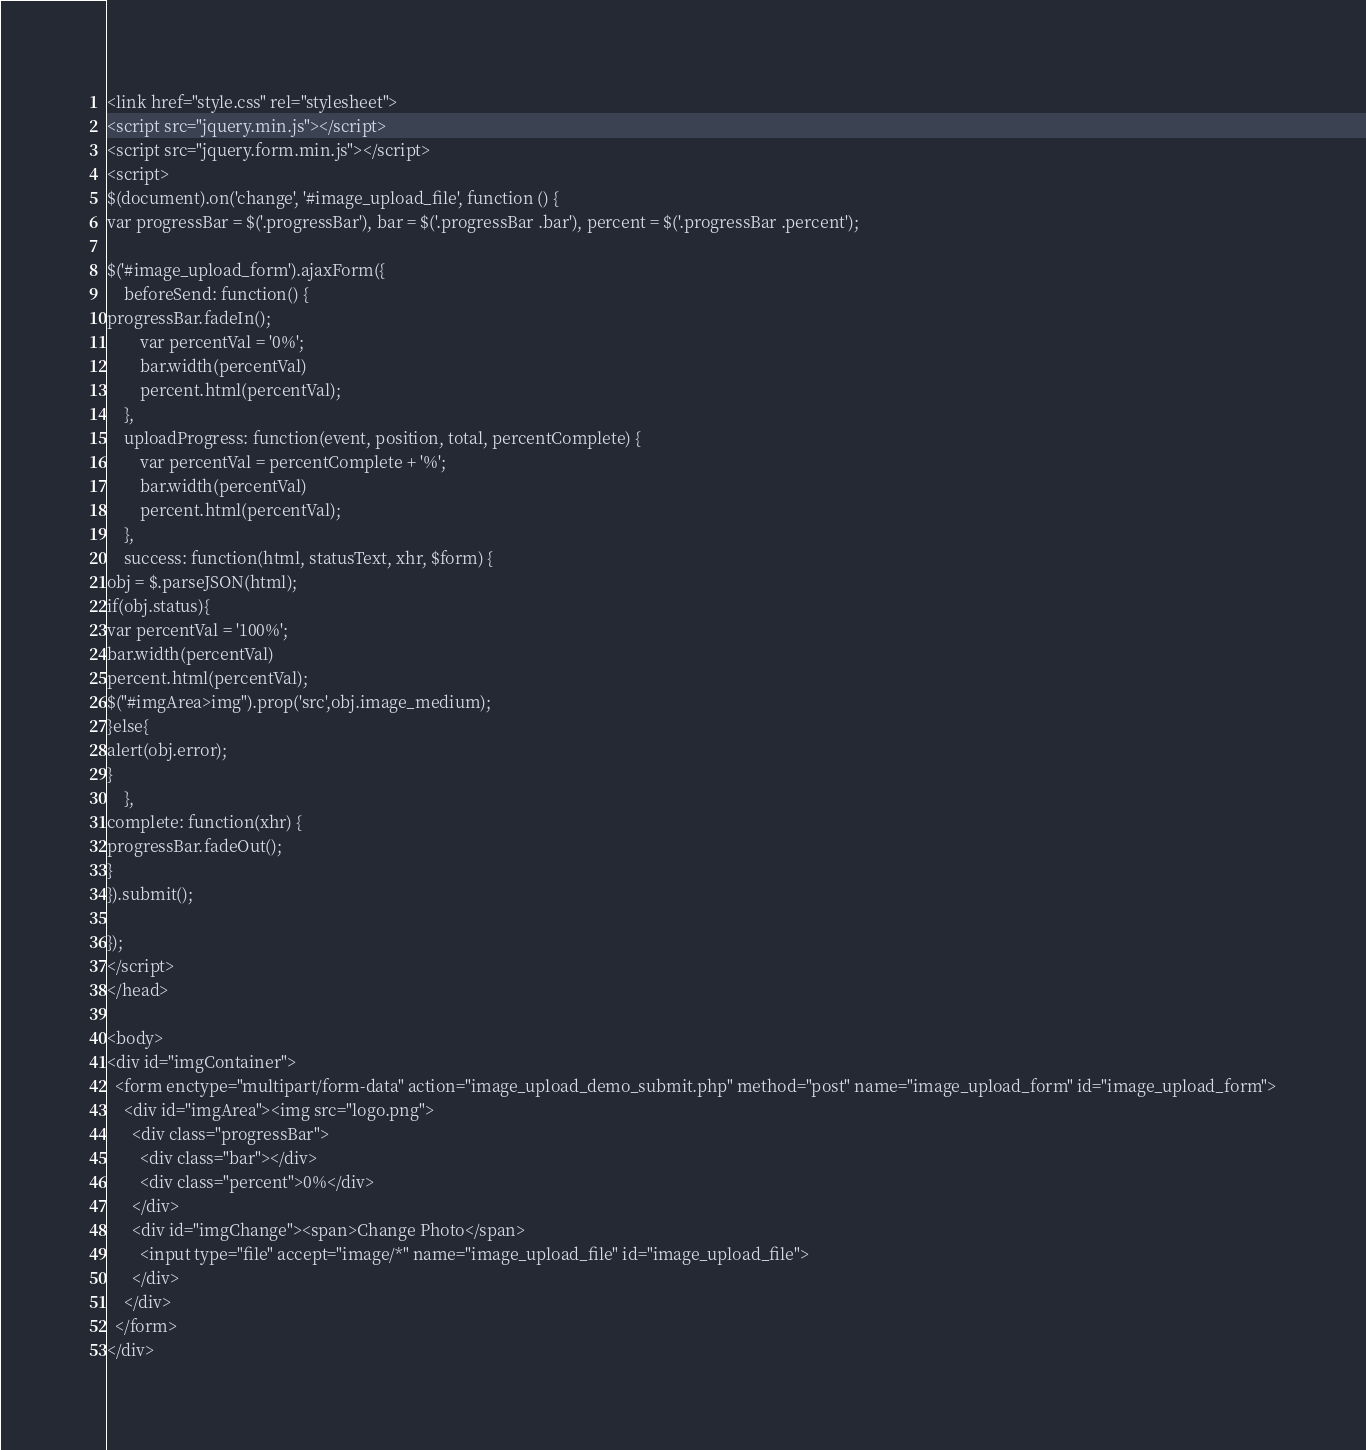Convert code to text. <code><loc_0><loc_0><loc_500><loc_500><_PHP_><link href="style.css" rel="stylesheet">
<script src="jquery.min.js"></script>
<script src="jquery.form.min.js"></script>
<script>
$(document).on('change', '#image_upload_file', function () {
var progressBar = $('.progressBar'), bar = $('.progressBar .bar'), percent = $('.progressBar .percent');

$('#image_upload_form').ajaxForm({
    beforeSend: function() {
progressBar.fadeIn();
        var percentVal = '0%';
        bar.width(percentVal)
        percent.html(percentVal);
    },
    uploadProgress: function(event, position, total, percentComplete) {
        var percentVal = percentComplete + '%';
        bar.width(percentVal)
        percent.html(percentVal);
    },
    success: function(html, statusText, xhr, $form) {
obj = $.parseJSON(html);
if(obj.status){
var percentVal = '100%';
bar.width(percentVal)
percent.html(percentVal);
$("#imgArea>img").prop('src',obj.image_medium);
}else{
alert(obj.error);
}
    },
complete: function(xhr) {
progressBar.fadeOut();
}
}).submit();

});
</script>
</head>

<body>
<div id="imgContainer">
  <form enctype="multipart/form-data" action="image_upload_demo_submit.php" method="post" name="image_upload_form" id="image_upload_form">
    <div id="imgArea"><img src="logo.png">
      <div class="progressBar">
        <div class="bar"></div>
        <div class="percent">0%</div>
      </div>
      <div id="imgChange"><span>Change Photo</span>
        <input type="file" accept="image/*" name="image_upload_file" id="image_upload_file">
      </div>
    </div>
  </form>
</div></code> 